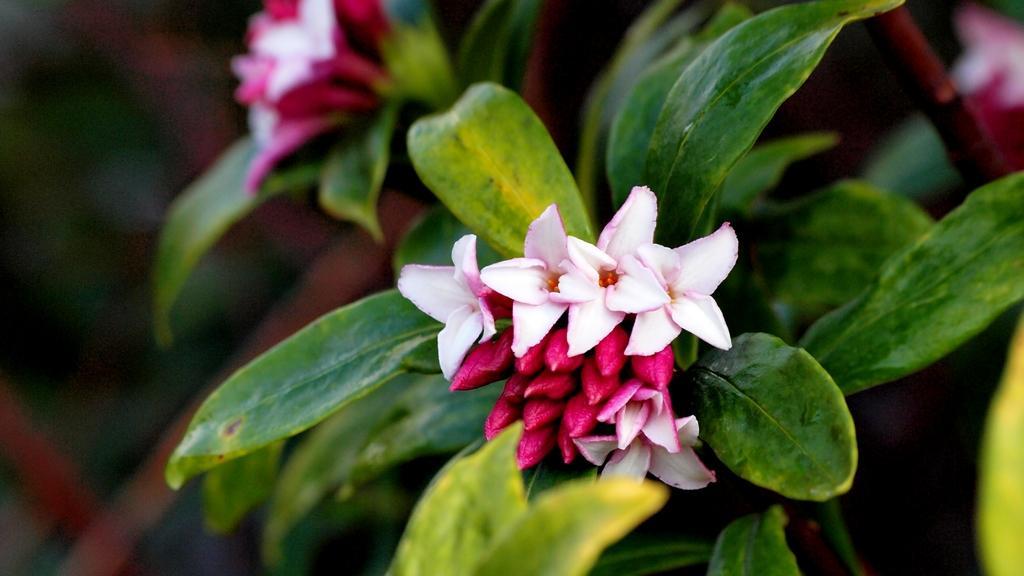Describe this image in one or two sentences. In this image there are flowers and leaves, in the background it is blurred. 